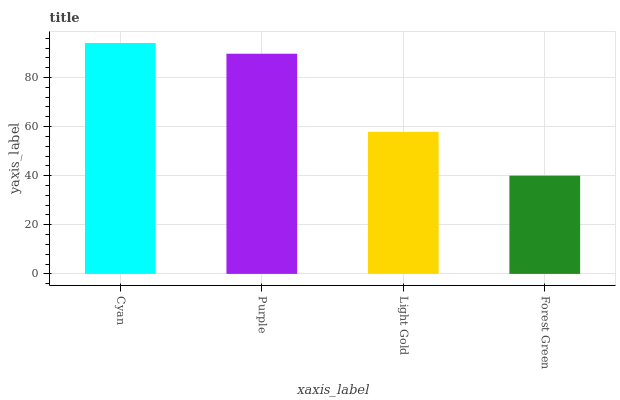Is Forest Green the minimum?
Answer yes or no. Yes. Is Cyan the maximum?
Answer yes or no. Yes. Is Purple the minimum?
Answer yes or no. No. Is Purple the maximum?
Answer yes or no. No. Is Cyan greater than Purple?
Answer yes or no. Yes. Is Purple less than Cyan?
Answer yes or no. Yes. Is Purple greater than Cyan?
Answer yes or no. No. Is Cyan less than Purple?
Answer yes or no. No. Is Purple the high median?
Answer yes or no. Yes. Is Light Gold the low median?
Answer yes or no. Yes. Is Light Gold the high median?
Answer yes or no. No. Is Cyan the low median?
Answer yes or no. No. 